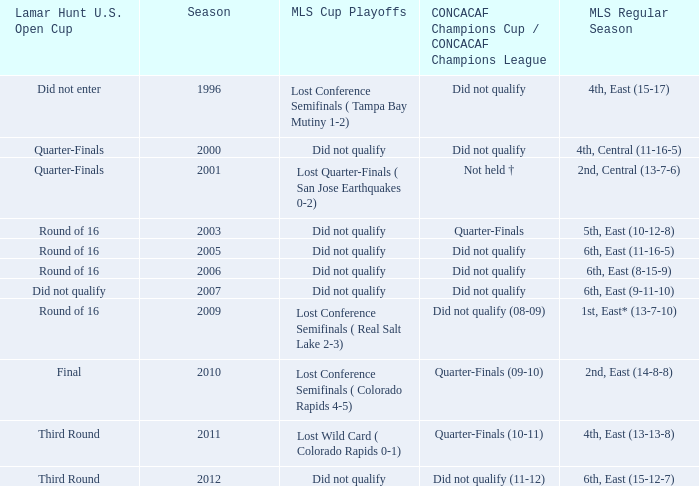What was the mls cup playoffs when concacaf champions cup / concacaf champions league was quarter-finals (09-10)? Lost Conference Semifinals ( Colorado Rapids 4-5). 